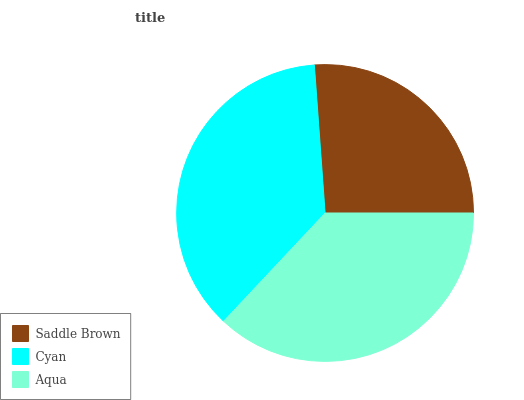Is Saddle Brown the minimum?
Answer yes or no. Yes. Is Aqua the maximum?
Answer yes or no. Yes. Is Cyan the minimum?
Answer yes or no. No. Is Cyan the maximum?
Answer yes or no. No. Is Cyan greater than Saddle Brown?
Answer yes or no. Yes. Is Saddle Brown less than Cyan?
Answer yes or no. Yes. Is Saddle Brown greater than Cyan?
Answer yes or no. No. Is Cyan less than Saddle Brown?
Answer yes or no. No. Is Cyan the high median?
Answer yes or no. Yes. Is Cyan the low median?
Answer yes or no. Yes. Is Aqua the high median?
Answer yes or no. No. Is Aqua the low median?
Answer yes or no. No. 